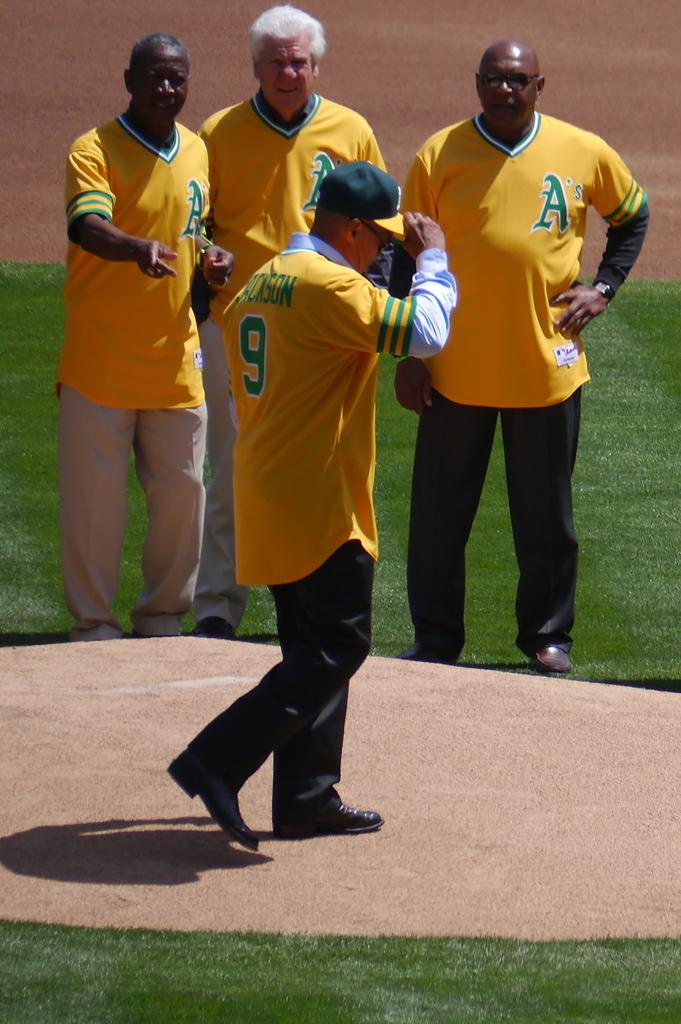<image>
Present a compact description of the photo's key features. number 9 looks disappointed as people make comments 